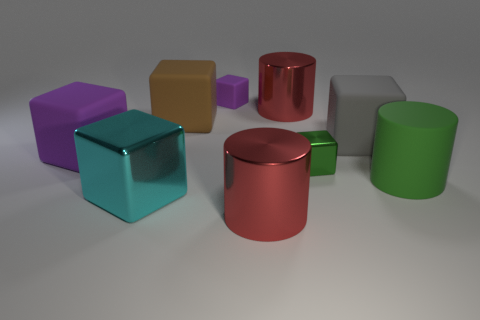Subtract all brown blocks. How many blocks are left? 5 Subtract all tiny metal cubes. How many cubes are left? 5 Subtract all blue blocks. Subtract all brown cylinders. How many blocks are left? 6 Subtract all blocks. How many objects are left? 3 Subtract all rubber objects. Subtract all big rubber spheres. How many objects are left? 4 Add 1 gray rubber objects. How many gray rubber objects are left? 2 Add 4 large purple balls. How many large purple balls exist? 4 Subtract 1 green cylinders. How many objects are left? 8 